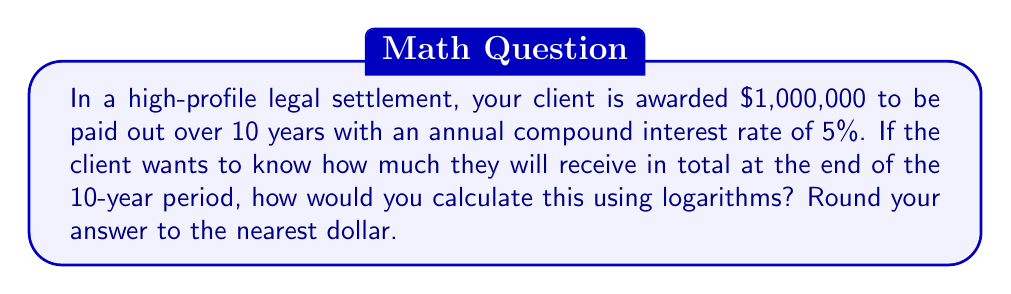Can you answer this question? To solve this problem using logarithms, we'll follow these steps:

1) The formula for compound interest is:
   $$A = P(1 + r)^t$$
   Where:
   A = final amount
   P = principal (initial investment)
   r = annual interest rate (as a decimal)
   t = time in years

2) We know:
   P = $1,000,000
   r = 5% = 0.05
   t = 10 years

3) Substituting these values:
   $$A = 1,000,000(1 + 0.05)^{10}$$

4) To solve this using logarithms, we can take the logarithm of both sides:
   $$\log A = \log[1,000,000(1.05)^{10}]$$

5) Using the logarithm property $\log(x^n) = n\log(x)$:
   $$\log A = \log(1,000,000) + 10\log(1.05)$$

6) Using a calculator or logarithm tables:
   $$\log A = 6 + 10(0.0212) = 6 + 0.212 = 6.212$$

7) To get A, we need to take the antilog (10^x) of both sides:
   $$A = 10^{6.212} = 1,628,894.63$$

8) Rounding to the nearest dollar:
   $$A ≈ $1,628,895$$
Answer: $1,628,895 